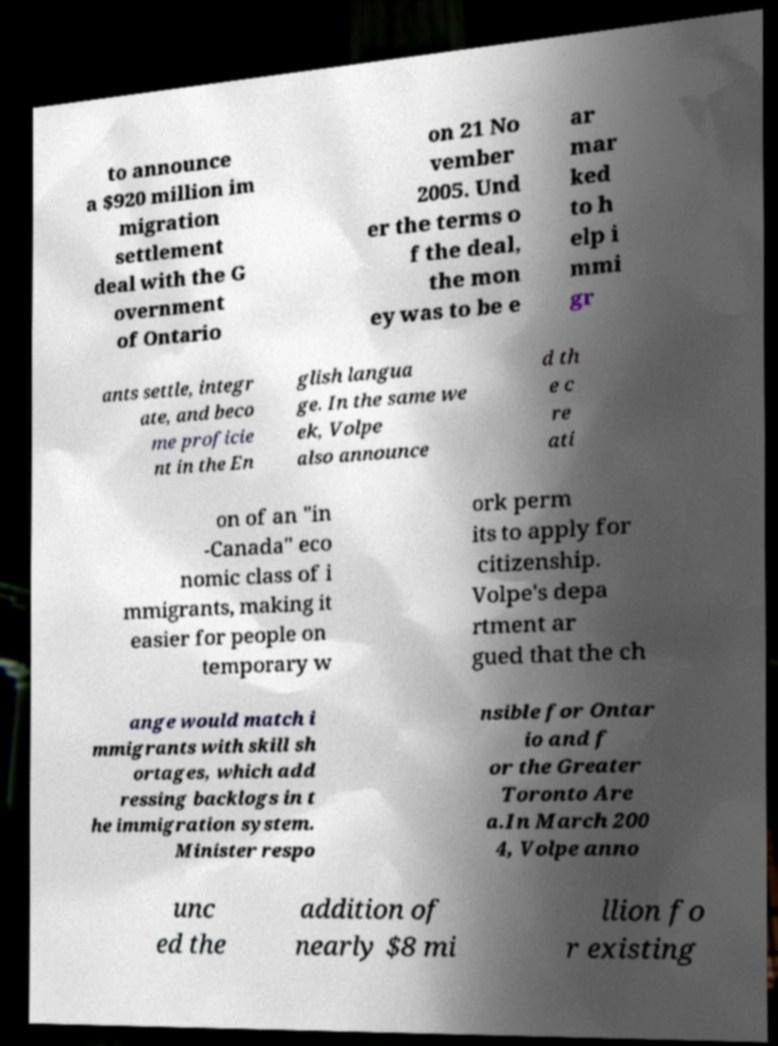Can you accurately transcribe the text from the provided image for me? to announce a $920 million im migration settlement deal with the G overnment of Ontario on 21 No vember 2005. Und er the terms o f the deal, the mon ey was to be e ar mar ked to h elp i mmi gr ants settle, integr ate, and beco me proficie nt in the En glish langua ge. In the same we ek, Volpe also announce d th e c re ati on of an "in -Canada" eco nomic class of i mmigrants, making it easier for people on temporary w ork perm its to apply for citizenship. Volpe's depa rtment ar gued that the ch ange would match i mmigrants with skill sh ortages, which add ressing backlogs in t he immigration system. Minister respo nsible for Ontar io and f or the Greater Toronto Are a.In March 200 4, Volpe anno unc ed the addition of nearly $8 mi llion fo r existing 